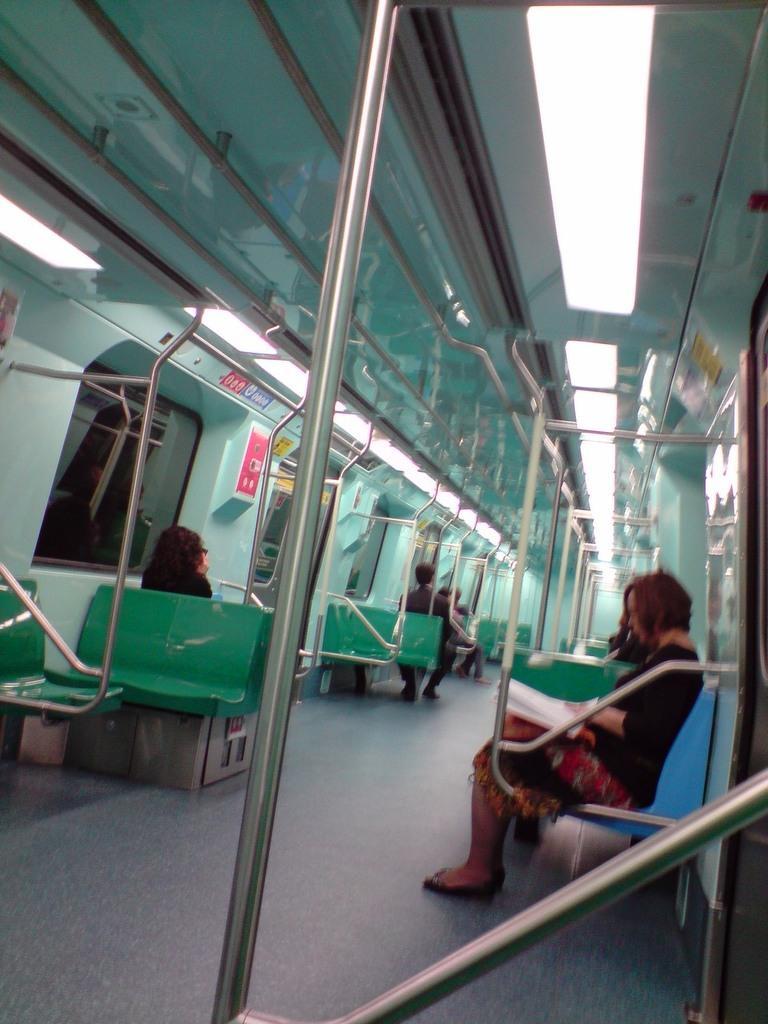Describe this image in one or two sentences. In this image I can see few people sitting on the chairs. And these people are wearing the different color dresses. To the side there are windows and some papers attached to the wall. And this is the inside part of vehicle. 